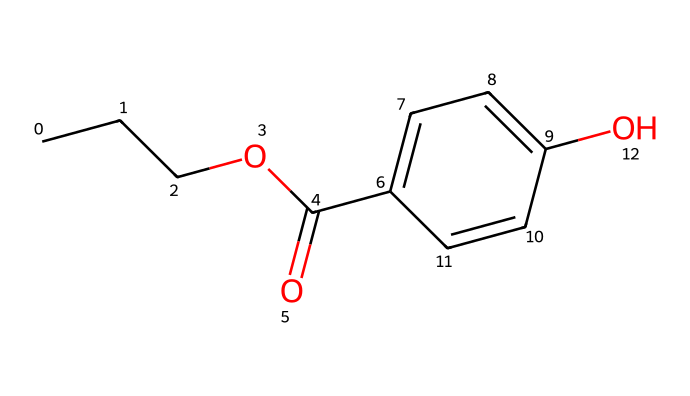What is the total number of carbon atoms in propylparaben? Counting the carbon atoms in the SMILES representation, we see three in the propyl group (CC), one in the carbonyl (C(=O)), and six in the aromatic ring (C1=CC=C(C=C1)), giving a total of 10 carbon atoms.
Answer: 10 How many hydroxyl groups (-OH) are present in propylparaben? In the SMILES representation, the presence of "O" in the part "C1=CC=C(C=C1)O" indicates the hydroxyl group on the aromatic ring. There is only one -OH group in the chemical structure.
Answer: 1 What is the functional group associated with the "OC(=O)" part of propylparaben? The "OC(=O)" part of the SMILES notation represents an ester functional group, which is commonly found in preservatives. The "O" indicates an oxygen atom is part of an ester linking the propyl group to the aromatic structure.
Answer: ester What type of compound is propylparaben classified as? Propylparaben, as indicated by its structure containing ester and aromatic components, is classified as a paraben, which are widely used preservatives in cosmetics and personal care products to prevent microbial growth.
Answer: preservative How many double bonds are present in the propylparaben structure? Looking at the SMILES, the structure contains three double bonds indicated in the aromatic ring (the "C=C" parts). Each pair of adjacent "C" in that section shows a double bond.
Answer: 3 What indicates the presence of an aromatic system in the chemical structure of propylparaben? The presence of a cyclic structure with alternating double bonds, shown in "C1=CC=C(C=C1)", confirms that an aromatic system is present; it consists of a six-membered ring and obeys Huckel's rule for aromaticity.
Answer: aromatic system 